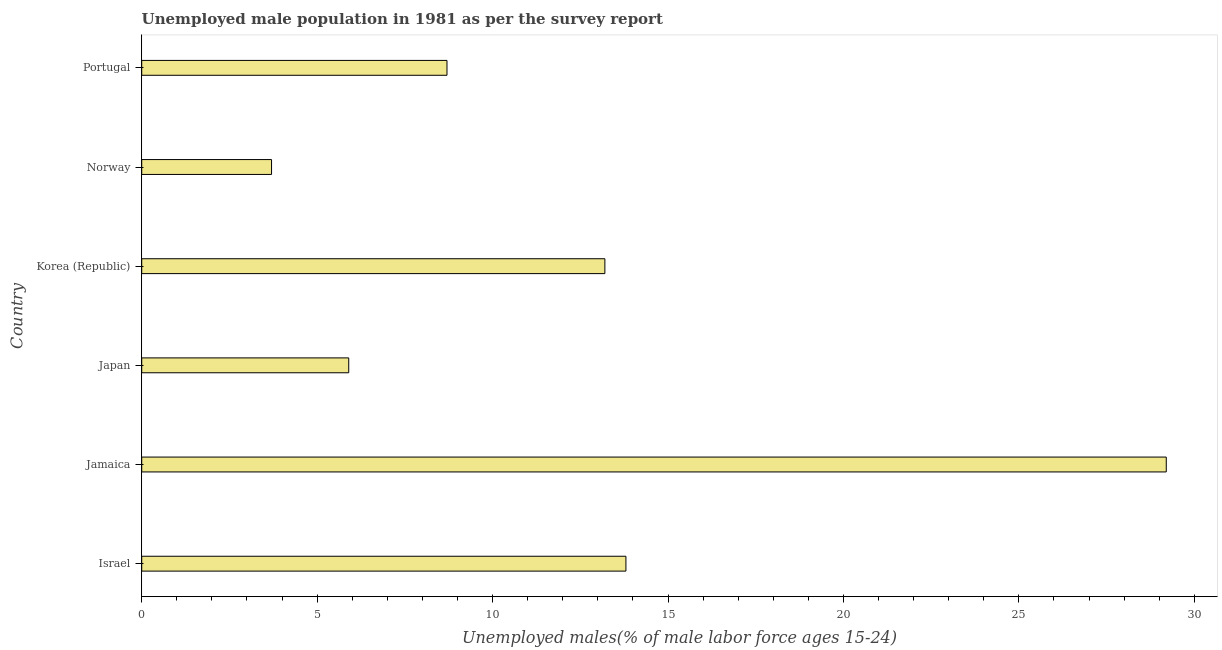Does the graph contain any zero values?
Your answer should be compact. No. What is the title of the graph?
Your answer should be compact. Unemployed male population in 1981 as per the survey report. What is the label or title of the X-axis?
Ensure brevity in your answer.  Unemployed males(% of male labor force ages 15-24). What is the label or title of the Y-axis?
Provide a short and direct response. Country. What is the unemployed male youth in Israel?
Ensure brevity in your answer.  13.8. Across all countries, what is the maximum unemployed male youth?
Make the answer very short. 29.2. Across all countries, what is the minimum unemployed male youth?
Ensure brevity in your answer.  3.7. In which country was the unemployed male youth maximum?
Keep it short and to the point. Jamaica. In which country was the unemployed male youth minimum?
Your response must be concise. Norway. What is the sum of the unemployed male youth?
Make the answer very short. 74.5. What is the average unemployed male youth per country?
Keep it short and to the point. 12.42. What is the median unemployed male youth?
Keep it short and to the point. 10.95. In how many countries, is the unemployed male youth greater than 28 %?
Make the answer very short. 1. What is the ratio of the unemployed male youth in Japan to that in Portugal?
Your response must be concise. 0.68. What is the difference between the highest and the lowest unemployed male youth?
Offer a terse response. 25.5. How many bars are there?
Ensure brevity in your answer.  6. What is the Unemployed males(% of male labor force ages 15-24) of Israel?
Offer a terse response. 13.8. What is the Unemployed males(% of male labor force ages 15-24) in Jamaica?
Provide a succinct answer. 29.2. What is the Unemployed males(% of male labor force ages 15-24) in Japan?
Keep it short and to the point. 5.9. What is the Unemployed males(% of male labor force ages 15-24) of Korea (Republic)?
Offer a terse response. 13.2. What is the Unemployed males(% of male labor force ages 15-24) of Norway?
Offer a very short reply. 3.7. What is the Unemployed males(% of male labor force ages 15-24) of Portugal?
Give a very brief answer. 8.7. What is the difference between the Unemployed males(% of male labor force ages 15-24) in Israel and Jamaica?
Your answer should be compact. -15.4. What is the difference between the Unemployed males(% of male labor force ages 15-24) in Israel and Norway?
Provide a short and direct response. 10.1. What is the difference between the Unemployed males(% of male labor force ages 15-24) in Israel and Portugal?
Provide a succinct answer. 5.1. What is the difference between the Unemployed males(% of male labor force ages 15-24) in Jamaica and Japan?
Ensure brevity in your answer.  23.3. What is the difference between the Unemployed males(% of male labor force ages 15-24) in Jamaica and Korea (Republic)?
Provide a short and direct response. 16. What is the difference between the Unemployed males(% of male labor force ages 15-24) in Jamaica and Portugal?
Make the answer very short. 20.5. What is the difference between the Unemployed males(% of male labor force ages 15-24) in Japan and Norway?
Make the answer very short. 2.2. What is the difference between the Unemployed males(% of male labor force ages 15-24) in Japan and Portugal?
Ensure brevity in your answer.  -2.8. What is the difference between the Unemployed males(% of male labor force ages 15-24) in Korea (Republic) and Norway?
Your answer should be very brief. 9.5. What is the difference between the Unemployed males(% of male labor force ages 15-24) in Korea (Republic) and Portugal?
Your answer should be compact. 4.5. What is the difference between the Unemployed males(% of male labor force ages 15-24) in Norway and Portugal?
Provide a succinct answer. -5. What is the ratio of the Unemployed males(% of male labor force ages 15-24) in Israel to that in Jamaica?
Your answer should be compact. 0.47. What is the ratio of the Unemployed males(% of male labor force ages 15-24) in Israel to that in Japan?
Keep it short and to the point. 2.34. What is the ratio of the Unemployed males(% of male labor force ages 15-24) in Israel to that in Korea (Republic)?
Keep it short and to the point. 1.04. What is the ratio of the Unemployed males(% of male labor force ages 15-24) in Israel to that in Norway?
Your response must be concise. 3.73. What is the ratio of the Unemployed males(% of male labor force ages 15-24) in Israel to that in Portugal?
Your response must be concise. 1.59. What is the ratio of the Unemployed males(% of male labor force ages 15-24) in Jamaica to that in Japan?
Provide a short and direct response. 4.95. What is the ratio of the Unemployed males(% of male labor force ages 15-24) in Jamaica to that in Korea (Republic)?
Make the answer very short. 2.21. What is the ratio of the Unemployed males(% of male labor force ages 15-24) in Jamaica to that in Norway?
Your answer should be compact. 7.89. What is the ratio of the Unemployed males(% of male labor force ages 15-24) in Jamaica to that in Portugal?
Ensure brevity in your answer.  3.36. What is the ratio of the Unemployed males(% of male labor force ages 15-24) in Japan to that in Korea (Republic)?
Provide a short and direct response. 0.45. What is the ratio of the Unemployed males(% of male labor force ages 15-24) in Japan to that in Norway?
Provide a short and direct response. 1.59. What is the ratio of the Unemployed males(% of male labor force ages 15-24) in Japan to that in Portugal?
Make the answer very short. 0.68. What is the ratio of the Unemployed males(% of male labor force ages 15-24) in Korea (Republic) to that in Norway?
Provide a short and direct response. 3.57. What is the ratio of the Unemployed males(% of male labor force ages 15-24) in Korea (Republic) to that in Portugal?
Your answer should be compact. 1.52. What is the ratio of the Unemployed males(% of male labor force ages 15-24) in Norway to that in Portugal?
Your answer should be compact. 0.42. 